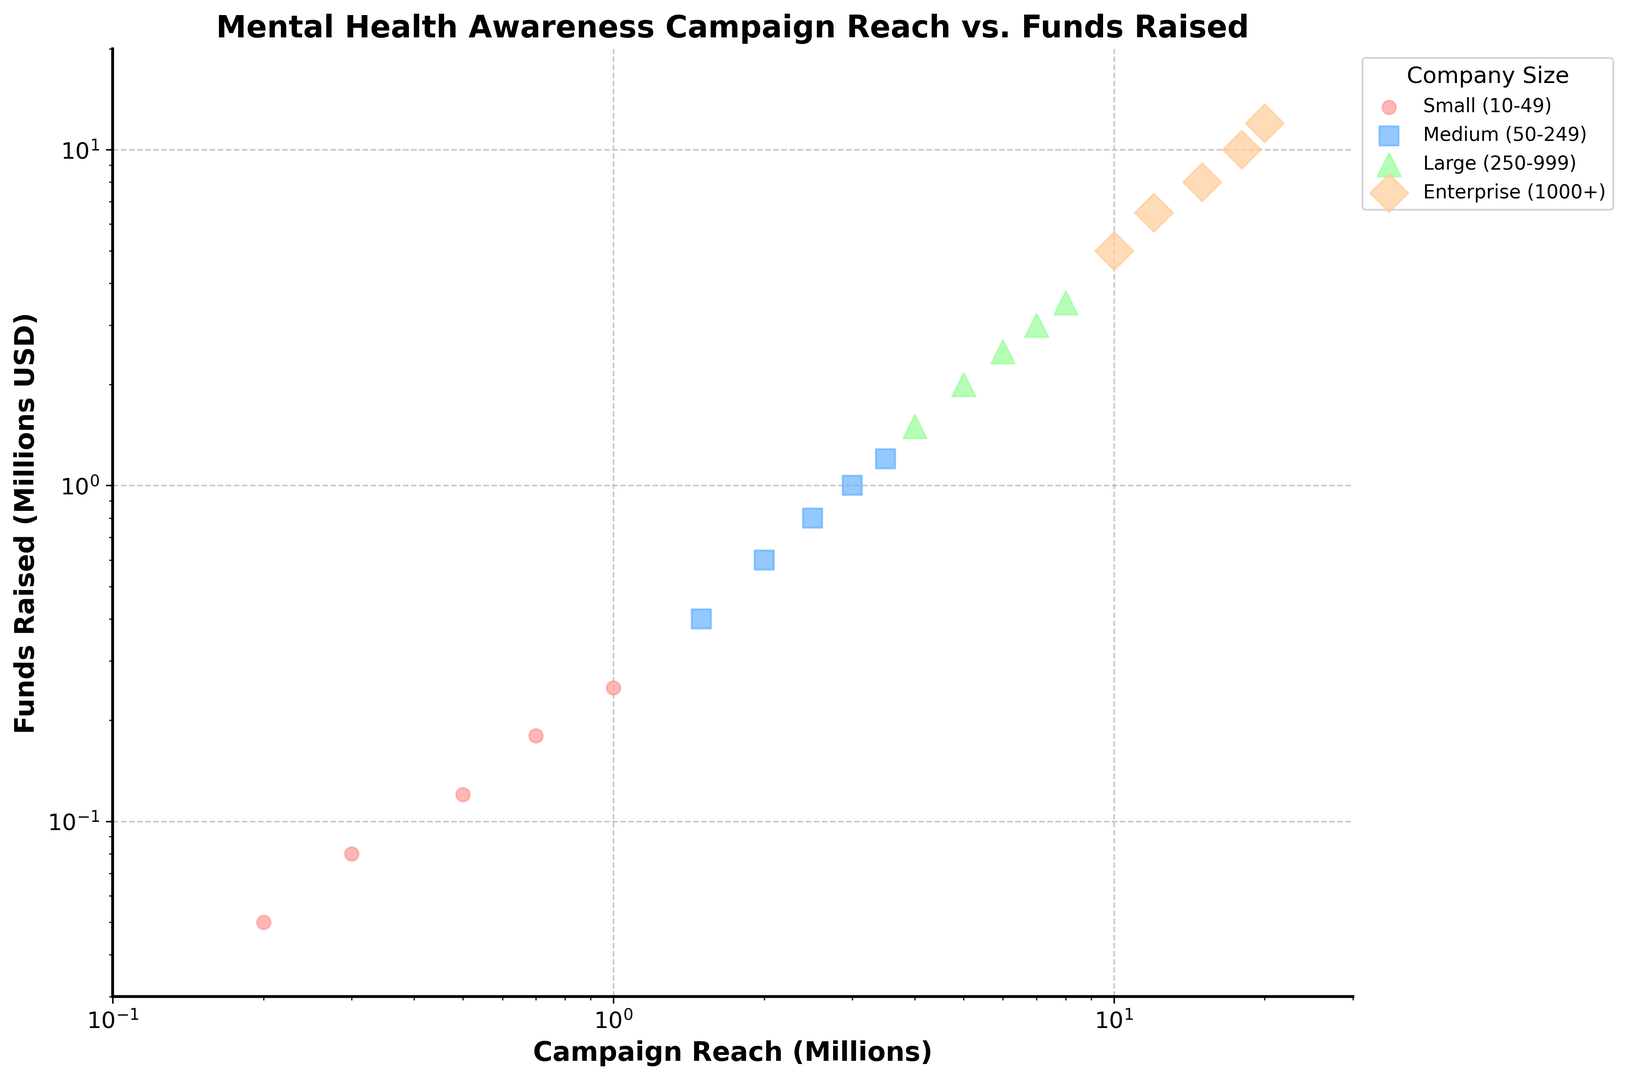What's the pattern of the relationship between campaign reach and funds raised for small-sized companies? To determine the pattern, look at the cluster of points for "Small (10-49)" with the orange color. The points are increasing in both x (Campaign Reach) and y (Funds Raised), indicating a positive correlation between campaign reach and funds raised for small-sized companies.
Answer: Positive correlation For the company size Medium (50-249), what is the range of campaign reach (in millions)? Look at the blue-colored scatter points representing "Medium (50-249)". The lowest x-value is 1.5 million, and the highest x-value is 3.5 million, giving a range of 1.5 to 3.5 million.
Answer: 1.5 to 3.5 million Which company size has the highest funds raised and what is the value? Find the data point with the highest y-value (green-colored diamond shape). It corresponds to the "Enterprise (1000+)" company size, with a funds raised value of 12 million USD.
Answer: Enterprise (1000+), 12 million USD How does the range of funds raised for Large (250-999) companies compare to that of Small (10-49) companies? The range for "Large (250-999)" (red-colored triangles) spans from 1.5 million to 3.5 million USD. For "Small (10-49)" (orange-colored circles), the range is from 0.05 million to 0.25 million USD. The range for Large companies is both wider and positioned at higher values compared to Small companies.
Answer: Larger and higher range What is the total funds raised by Medium-sized companies (50-249)? Identify each point corresponding to "Medium (50-249)" (blue-colored squares) and sum their y-values: 0.4 + 0.6 + 0.8 + 1.0 + 1.2 = 4.0 million USD.
Answer: 4.0 million USD Which color represents the data for Large companies and how can you tell? The Large companies are depicted by green-colored triangular marks identified from the legend to the upper right of the scatter plot at the nearest to these exact symbols.
Answer: Green Among the four company sizes, which has the narrowest range for campaign reach, and what is that range? Inspect the x-axis range for each company size. Small (10-49) companies range from 0.2 to 1.0 million (0.8 million), Medium (50-249) from 1.5 to 3.5 million (2.0 million), Large (250-999) from 4.0 to 8.0 million (4.0 million), and Enterprise (1000+) from 10.0 to 20.0 million (10.0 million). The narrowest range is for Small companies, 0.8 million.
Answer: Small (10-49), 0.8 million For Enterprise companies, what is the median value of campaign reach? Note the x-values for "Enterprise (1000+)" (purple-colored diamonds): 10, 12, 15, 18, and 20 million. The median of these values is the middle one, which is 15 million.
Answer: 15 million How does the highest funds raised by Medium-sized companies compare to the lowest funds raised by Large companies? The highest funds raised by Medium companies (blue squares) is 1.2 million USD. The lowest funds raised by Large companies (green triangles) is 1.5 million USD. Compare these values: 1.2 million < 1.5 million.
Answer: Medium < Large 